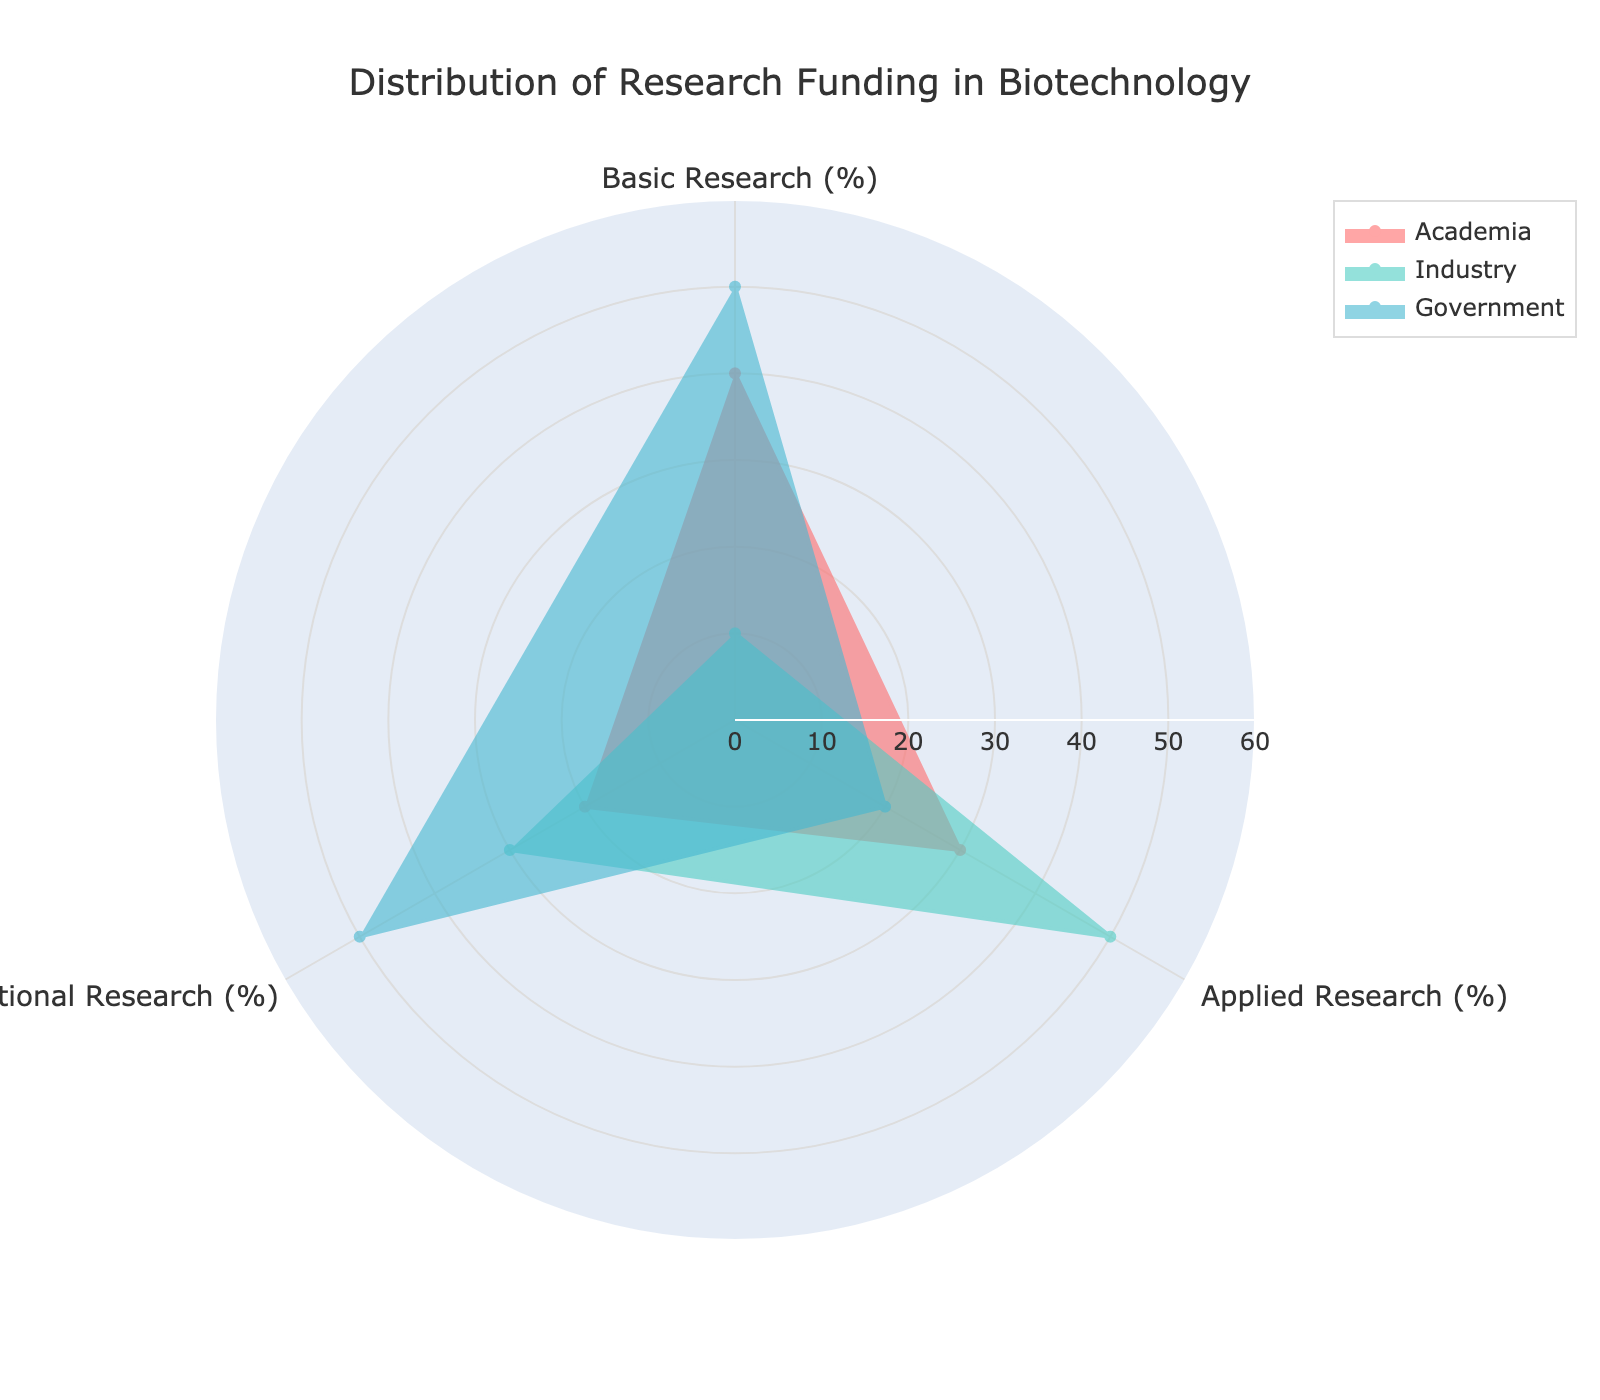Which funding source allocates the highest percentage to basic research? The plot shows that basic research is represented by the highest value for Government, followed by Academia, and lastly Industry. Government dominates this section with 50%.
Answer: Government What is the title of the radar chart? The title is clearly displayed at the top of the radar chart.
Answer: Distribution of Research Funding in Biotechnology Which group has the lowest percentage allocation in any research category? We have to look for the smallest value in each research section. Industry allocates 10% to basic research, which is the lowest.
Answer: Industry in Basic Research Compare Academia and Industry in terms of their applied research funding. Which allocates more? By observing the applied research section, Industry allocates 50% whereas Academia allocates 30%.
Answer: Industry How much more does Government allocate to translational research compared to Academia? Government allocates 50% while Academia allocates 20% to translational research. The difference is 50 - 20 = 30.
Answer: 30 What is the combined percentage of translational research funding from all sources? Academia, Industry, and Government allocate different percentages: 20% + 30% + 50%. Summing these: 20 + 30 + 50 = 100.
Answer: 100% Identify the sector with the most balanced allocation across all three research types. Examine the peaks and troughs for each sector. Academia shows more balance (40%, 30%, 20%) compared to others' higher fluctuations.
Answer: Academia Which research category receives the highest funding allocation from all sources combined? Summing up each research category: Basic (40 + 10 + 50 = 100), Applied (30 + 50 + 20 = 100), Translational (20 + 30 + 50 = 100). They are all the same at 100%.
Answer: All equal 